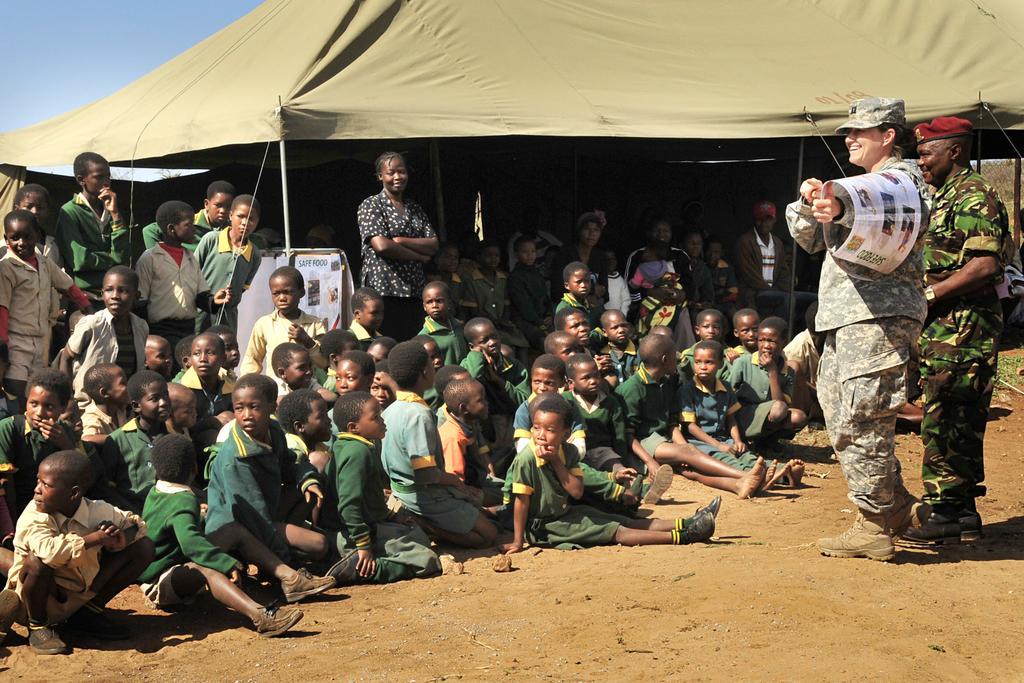Can you describe this image briefly? This picture is clicked outside. In the center we can see the group of children sitting on the ground and we can see the group of persons standing on the ground. In the background we can see the sky, tent and some other objects. 